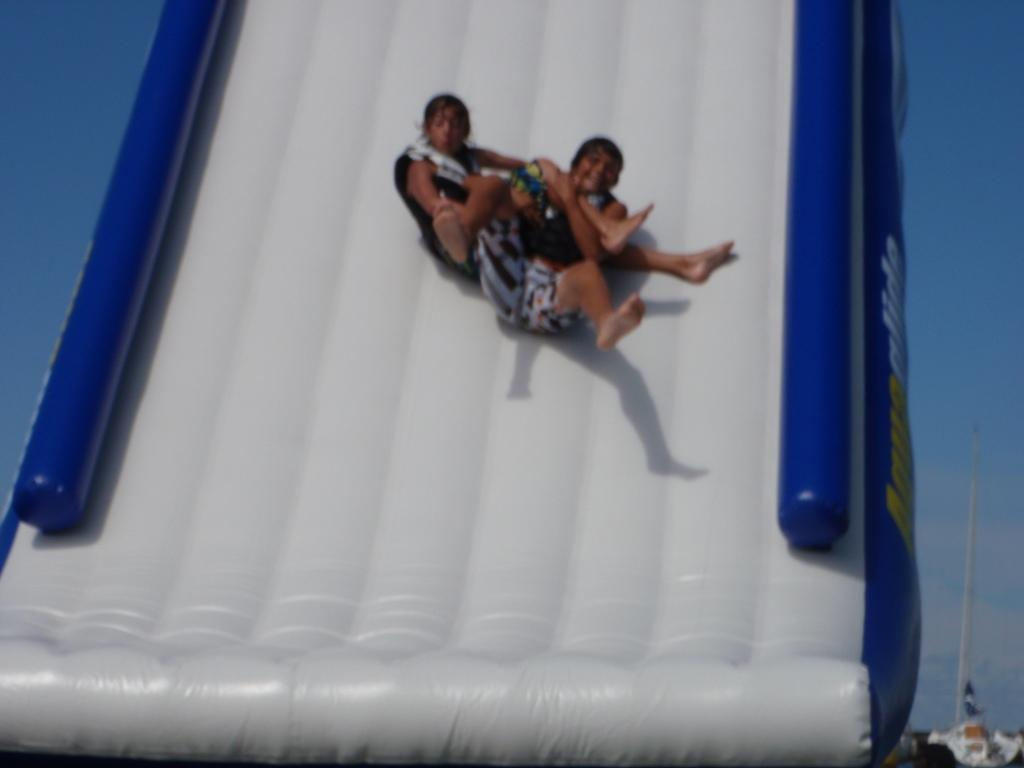How many people are in the image? There are two persons in the image. What are the two persons doing in the image? The two persons are sliding on an object. What is the condition of the sky in the image? The sky is clear and blue in the image. What type of muscle is being exercised by the persons in the image? There is no indication in the image of which muscles, if any, are being exercised by the persons. 